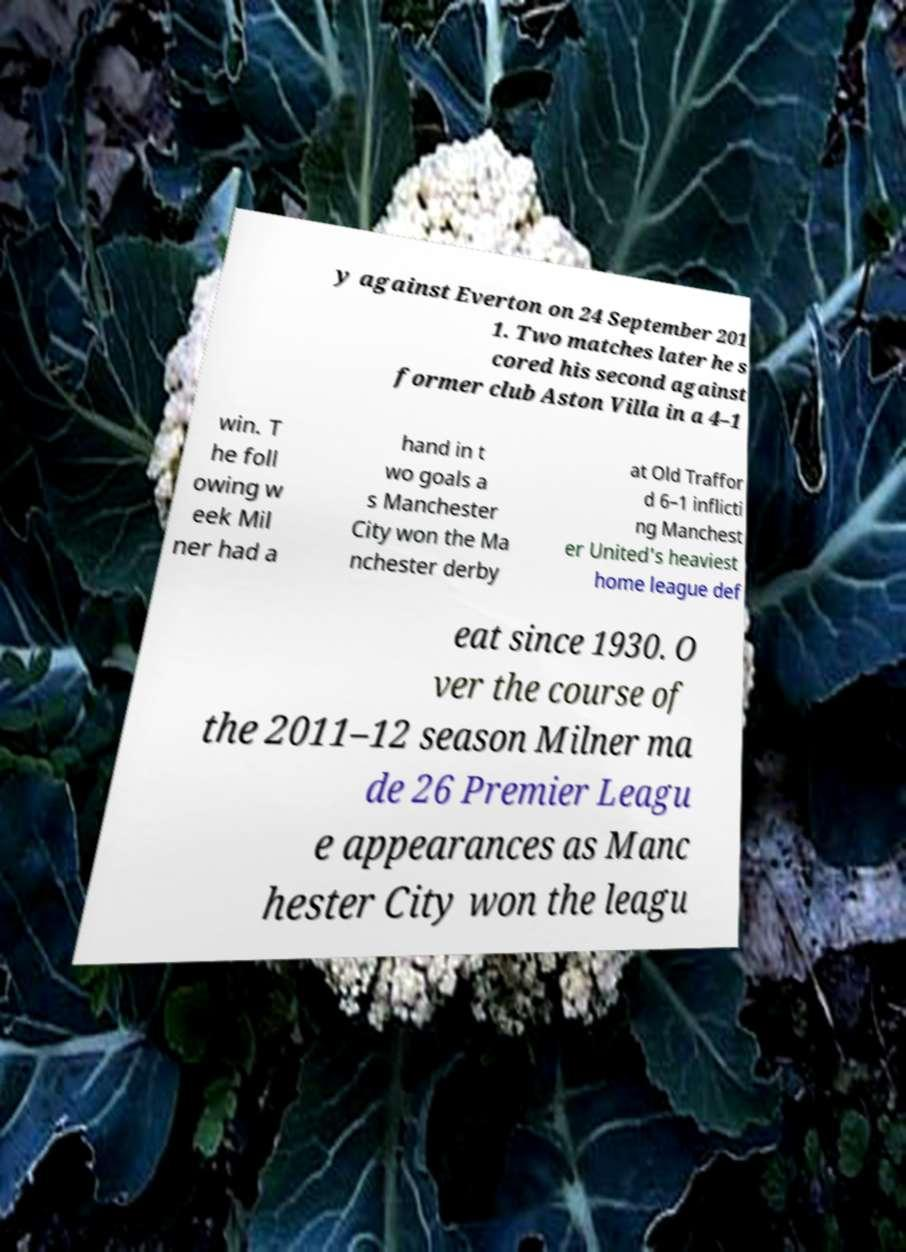Please read and relay the text visible in this image. What does it say? y against Everton on 24 September 201 1. Two matches later he s cored his second against former club Aston Villa in a 4–1 win. T he foll owing w eek Mil ner had a hand in t wo goals a s Manchester City won the Ma nchester derby at Old Traffor d 6–1 inflicti ng Manchest er United's heaviest home league def eat since 1930. O ver the course of the 2011–12 season Milner ma de 26 Premier Leagu e appearances as Manc hester City won the leagu 